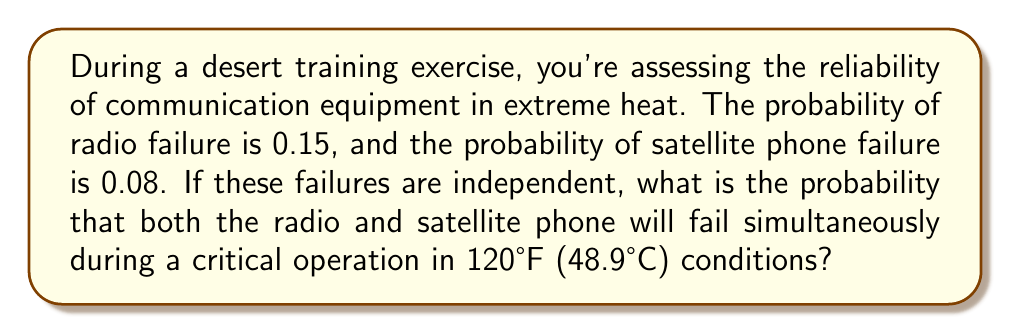Could you help me with this problem? Let's approach this step-by-step using the concept of joint probability for independent events:

1) Define the events:
   R: Radio failure
   S: Satellite phone failure

2) Given probabilities:
   P(R) = 0.15
   P(S) = 0.08

3) We need to find P(R and S), the probability of both failing simultaneously.

4) For independent events, the joint probability is the product of their individual probabilities:

   $$P(R \text{ and } S) = P(R) \times P(S)$$

5) Substituting the values:

   $$P(R \text{ and } S) = 0.15 \times 0.08$$

6) Calculate:

   $$P(R \text{ and } S) = 0.012$$

Therefore, the probability that both the radio and satellite phone will fail simultaneously is 0.012 or 1.2%.
Answer: 0.012 